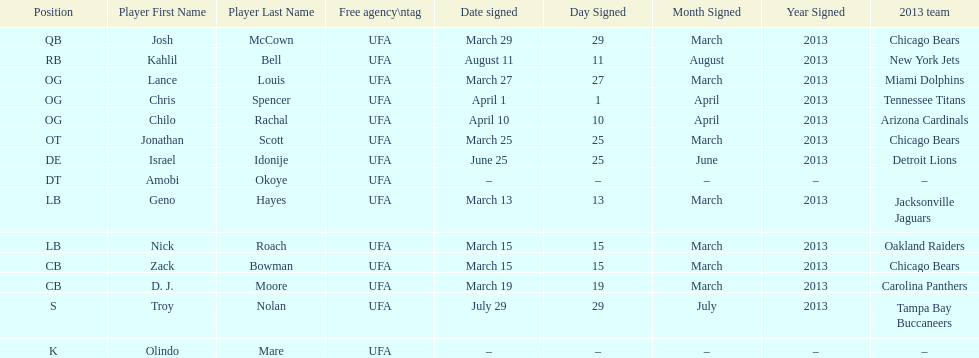Signed the same date as "april fools day". Chris Spencer. 